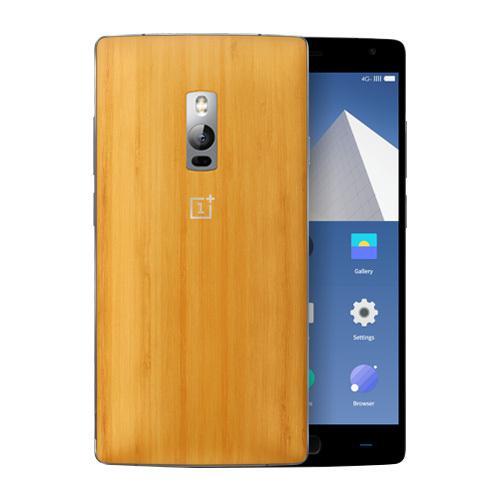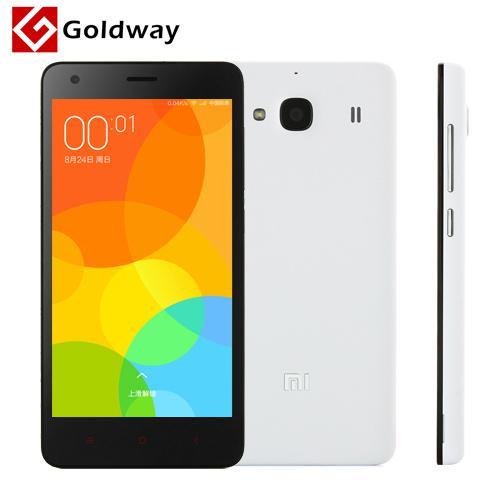The first image is the image on the left, the second image is the image on the right. Assess this claim about the two images: "At least one image features the side profile of a phone.". Correct or not? Answer yes or no. Yes. 